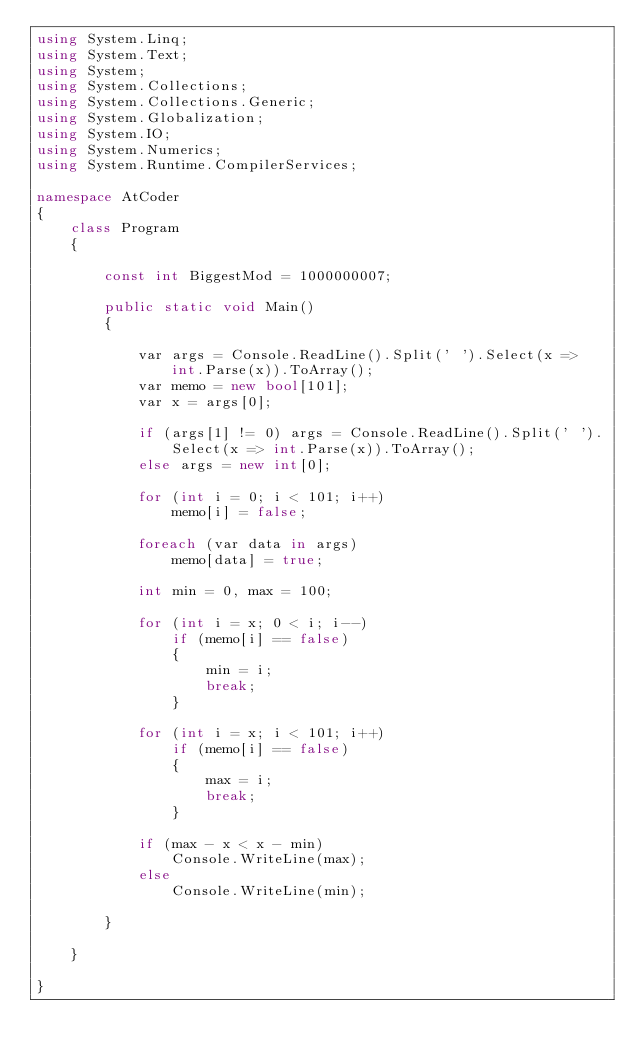<code> <loc_0><loc_0><loc_500><loc_500><_C#_>using System.Linq;
using System.Text;
using System;
using System.Collections;
using System.Collections.Generic;
using System.Globalization;
using System.IO;
using System.Numerics;
using System.Runtime.CompilerServices;

namespace AtCoder
{
    class Program
    {

        const int BiggestMod = 1000000007;

        public static void Main()
        {

            var args = Console.ReadLine().Split(' ').Select(x => int.Parse(x)).ToArray();
            var memo = new bool[101];
            var x = args[0];

            if (args[1] != 0) args = Console.ReadLine().Split(' ').Select(x => int.Parse(x)).ToArray();
            else args = new int[0];

            for (int i = 0; i < 101; i++)
                memo[i] = false;

            foreach (var data in args)
                memo[data] = true;

            int min = 0, max = 100;

            for (int i = x; 0 < i; i--)
                if (memo[i] == false)
                {
                    min = i;
                    break;
                }

            for (int i = x; i < 101; i++)
                if (memo[i] == false)
                {
                    max = i;
                    break;
                }

            if (max - x < x - min)
                Console.WriteLine(max);
            else
                Console.WriteLine(min);

        }

    }

}</code> 